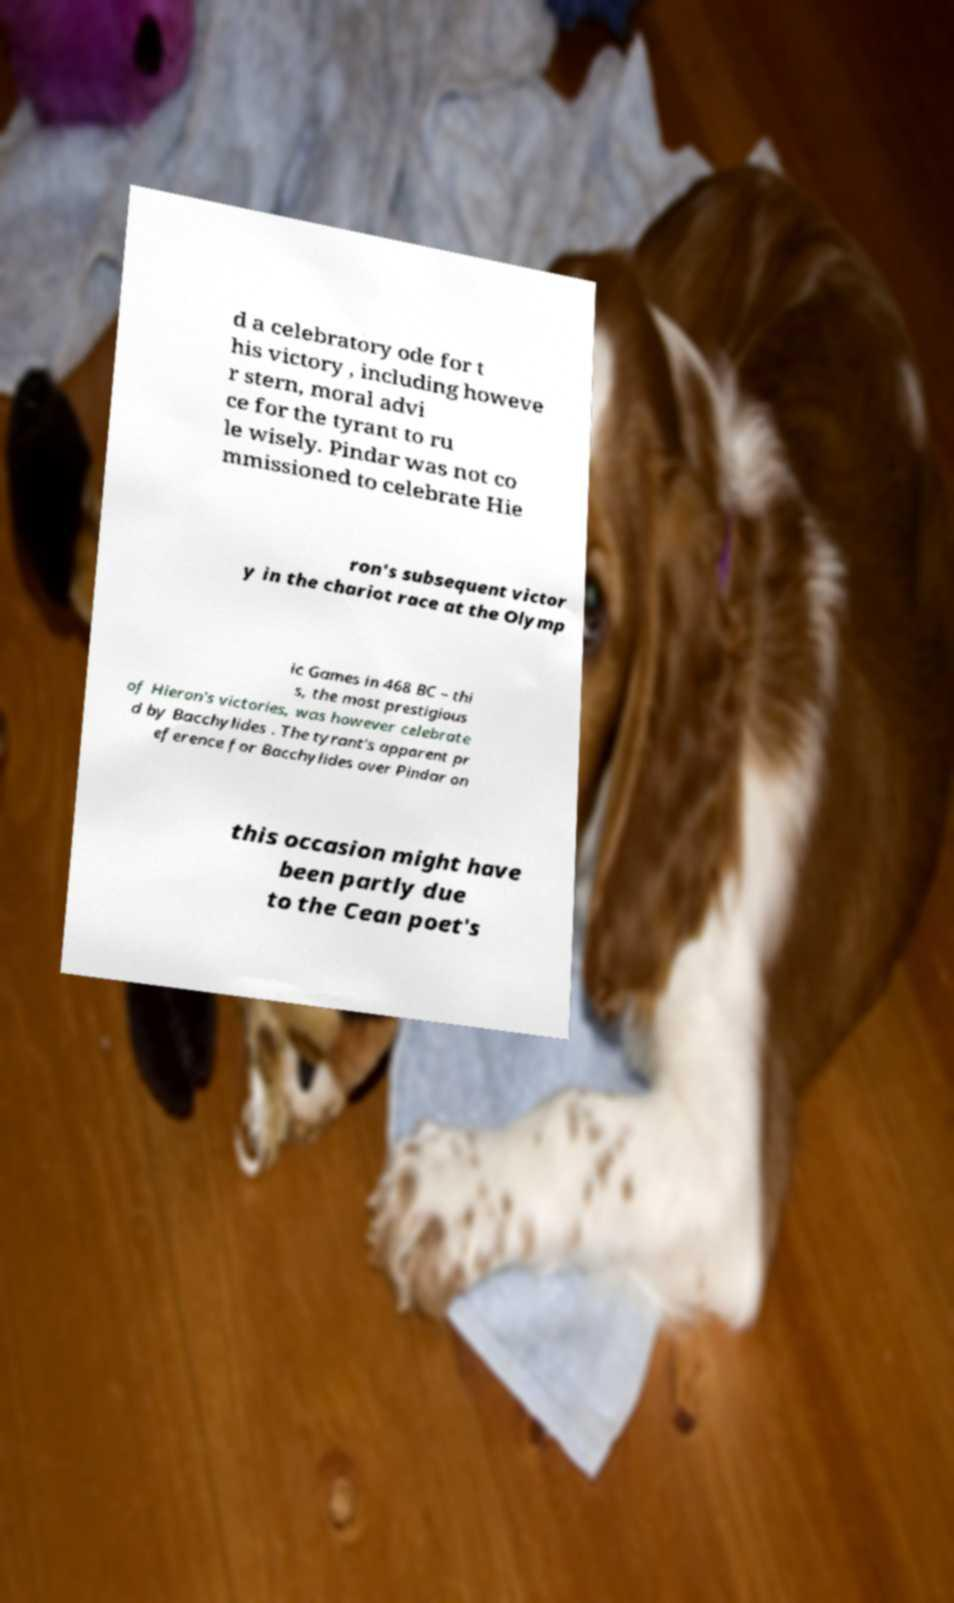Could you extract and type out the text from this image? d a celebratory ode for t his victory , including howeve r stern, moral advi ce for the tyrant to ru le wisely. Pindar was not co mmissioned to celebrate Hie ron's subsequent victor y in the chariot race at the Olymp ic Games in 468 BC – thi s, the most prestigious of Hieron's victories, was however celebrate d by Bacchylides . The tyrant's apparent pr eference for Bacchylides over Pindar on this occasion might have been partly due to the Cean poet's 